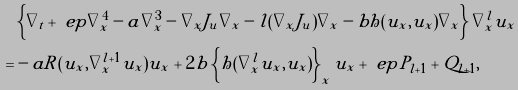Convert formula to latex. <formula><loc_0><loc_0><loc_500><loc_500>& \left \{ \nabla _ { t } + \ e p \nabla _ { x } ^ { 4 } - a \nabla _ { x } ^ { 3 } - \nabla _ { x } J _ { u } \nabla _ { x } - l ( \nabla _ { x } J _ { u } ) \nabla _ { x } - b h ( u _ { x } , u _ { x } ) \nabla _ { x } \right \} \nabla _ { x } ^ { l } u _ { x } \\ = & - a R ( u _ { x } , \nabla _ { x } ^ { l + 1 } u _ { x } ) u _ { x } + 2 b \left \{ h ( \nabla _ { x } ^ { l } u _ { x } , u _ { x } ) \right \} _ { x } u _ { x } + { \ e p } P _ { l + 1 } + Q _ { l + 1 } ,</formula> 